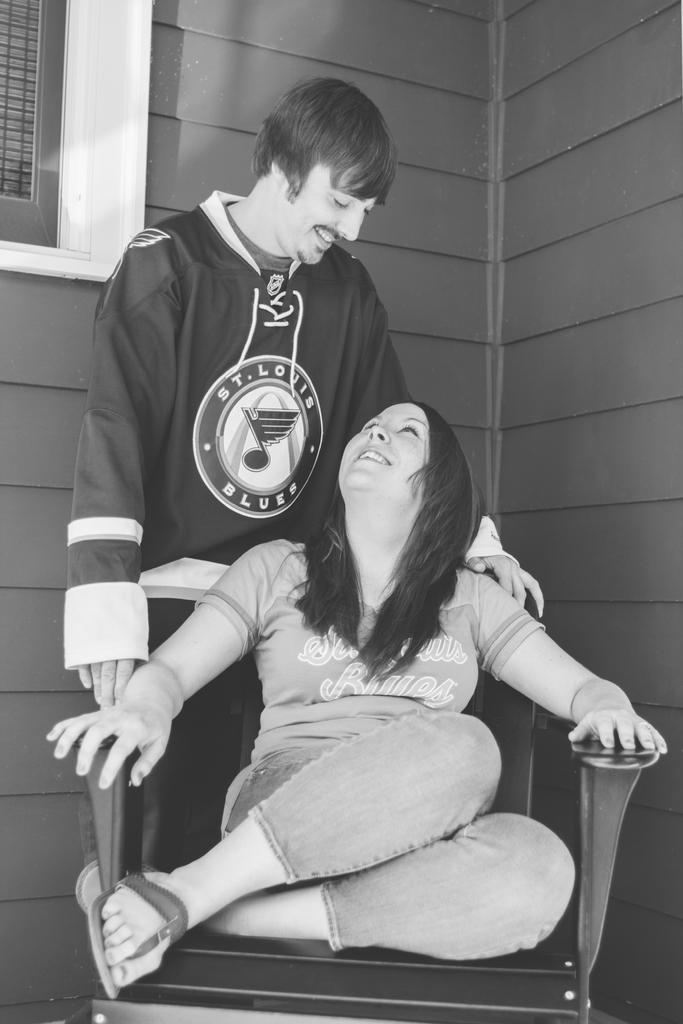Are they both fans of the same team?
Give a very brief answer. Yes. 